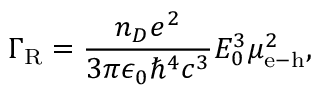<formula> <loc_0><loc_0><loc_500><loc_500>\Gamma _ { R } = \frac { n _ { D } e ^ { 2 } } { 3 \pi \epsilon _ { 0 } \hbar { ^ } { 4 } c ^ { 3 } } E _ { 0 } ^ { 3 } \mu _ { e - h } ^ { 2 } ,</formula> 